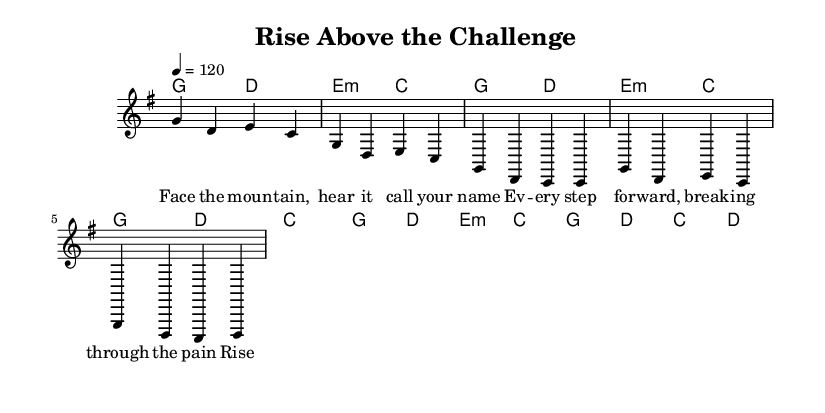What is the key signature of this music? The key signature for this piece is G major, which has one sharp (F#). This can be determined by observing the key signature denoted at the beginning of the staff.
Answer: G major What is the time signature of this music? The time signature indicated is 4/4, which is evident at the start of the music where it specifies that there are four beats per measure and the quarter note gets one beat.
Answer: 4/4 What is the tempo marking of this music? The tempo marking is a quarter note equals 120 beats per minute, as shown at the beginning of the score. This means that there are 120 quarter note beats in one minute.
Answer: 120 How many measures are in the verse section? By counting the distinct measures in the verse lyrics section provided, it can be seen that there are four measures labeled in the abbreviation.
Answer: Four What are the first two chords of the song? The first two chords listed in the harmonies section are G major and D major, which can be identified from the chord symbols placed above the melody at the beginning.
Answer: G and D What lyric corresponds to the first measure? The first measure of the verse contains the lyrics "Face the moun," which can be matched to the melody it represents in that respective measure.
Answer: Face the moun What is the main theme of the chorus lyrics? The chorus emphasizes overcoming challenges and proving oneself, as highlighted in the lyrics provided in that section, clearly expressing themes of resilience and determination.
Answer: Rise above the challenge 